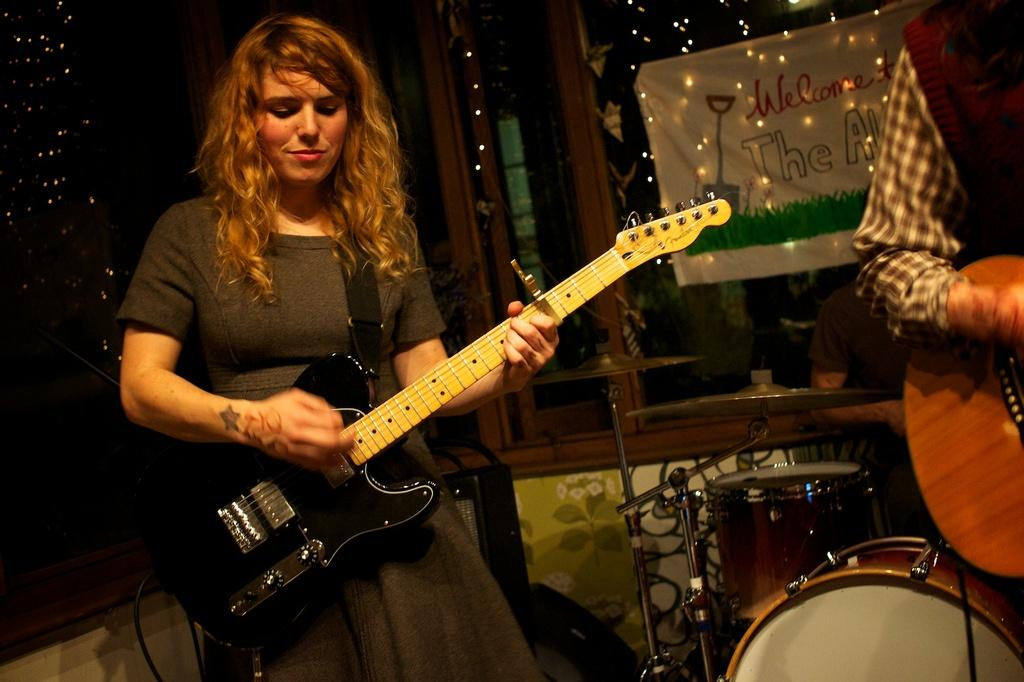What is the gender of the person in the image? The person in the image is a lady. What is the lady person wearing in the image? The lady person is wearing a black dress. What activity is the lady person engaged in? The lady person is playing a guitar. What type of wool is used to make the cover of the guitar in the image? There is no mention of a cover on the guitar in the image, nor is there any information about the material used to make it. 